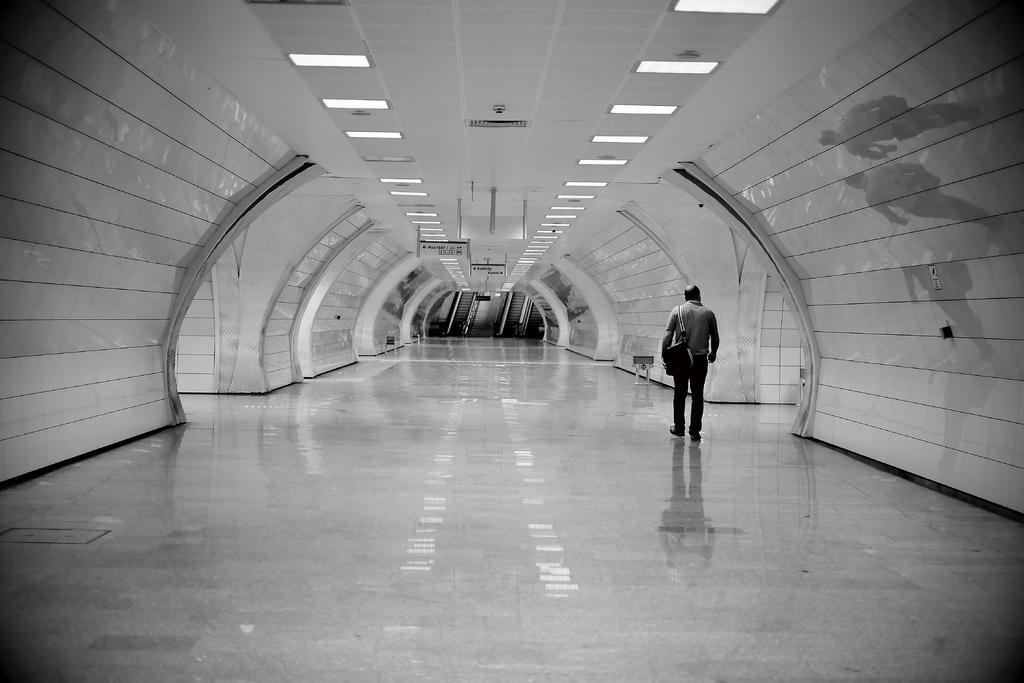Describe this image in one or two sentences. In this picture we can see the ceiling, lights and objects. We can see a man carrying a bag. On the right side of the picture we can see the reflection. At the bottom portion of the picture we can see the floor. 